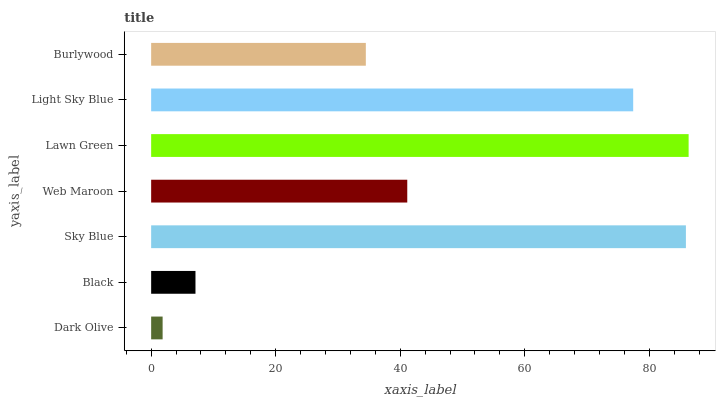Is Dark Olive the minimum?
Answer yes or no. Yes. Is Lawn Green the maximum?
Answer yes or no. Yes. Is Black the minimum?
Answer yes or no. No. Is Black the maximum?
Answer yes or no. No. Is Black greater than Dark Olive?
Answer yes or no. Yes. Is Dark Olive less than Black?
Answer yes or no. Yes. Is Dark Olive greater than Black?
Answer yes or no. No. Is Black less than Dark Olive?
Answer yes or no. No. Is Web Maroon the high median?
Answer yes or no. Yes. Is Web Maroon the low median?
Answer yes or no. Yes. Is Lawn Green the high median?
Answer yes or no. No. Is Dark Olive the low median?
Answer yes or no. No. 